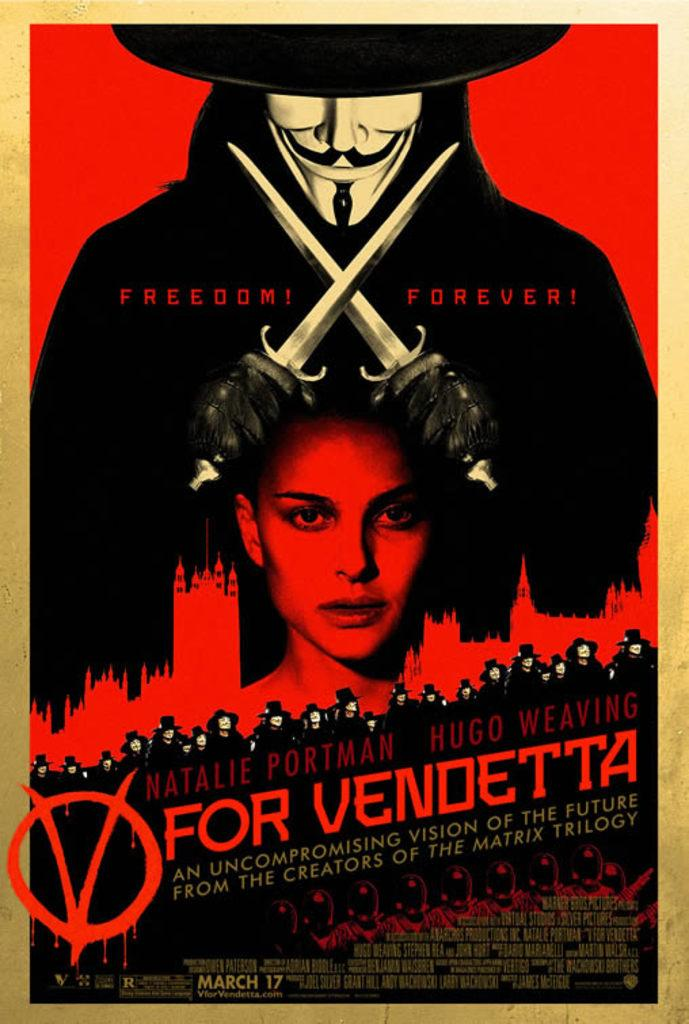<image>
Present a compact description of the photo's key features. A poster for the movie V for Vendetta with Natalie Portman on it. 